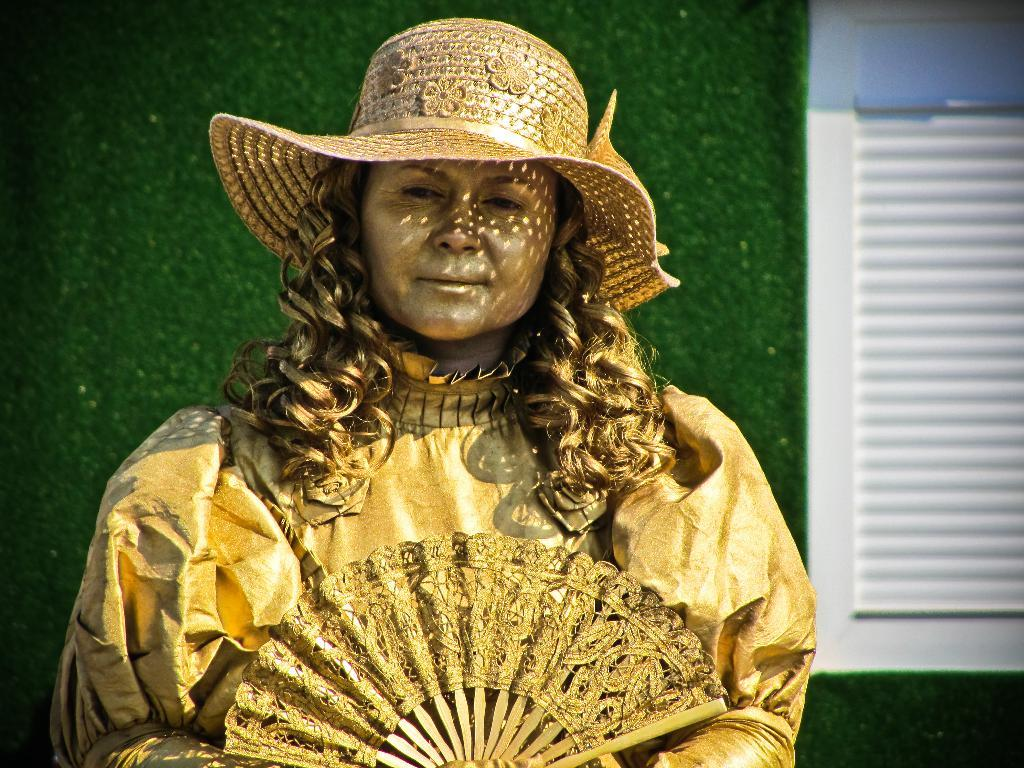Who is the main subject in the image? There is a girl in the image. What is the girl wearing? The girl is wearing a costume. What is the girl's posture in the image? The girl is standing. What can be seen in the background of the image? There is a wall in the background of the image. What architectural feature is present in the wall? There is a window in the wall. What is the girl's opinion on the carpenter's work in the image? There is no carpenter or any reference to carpentry work in the image, so it is not possible to determine the girl's opinion on the matter. 